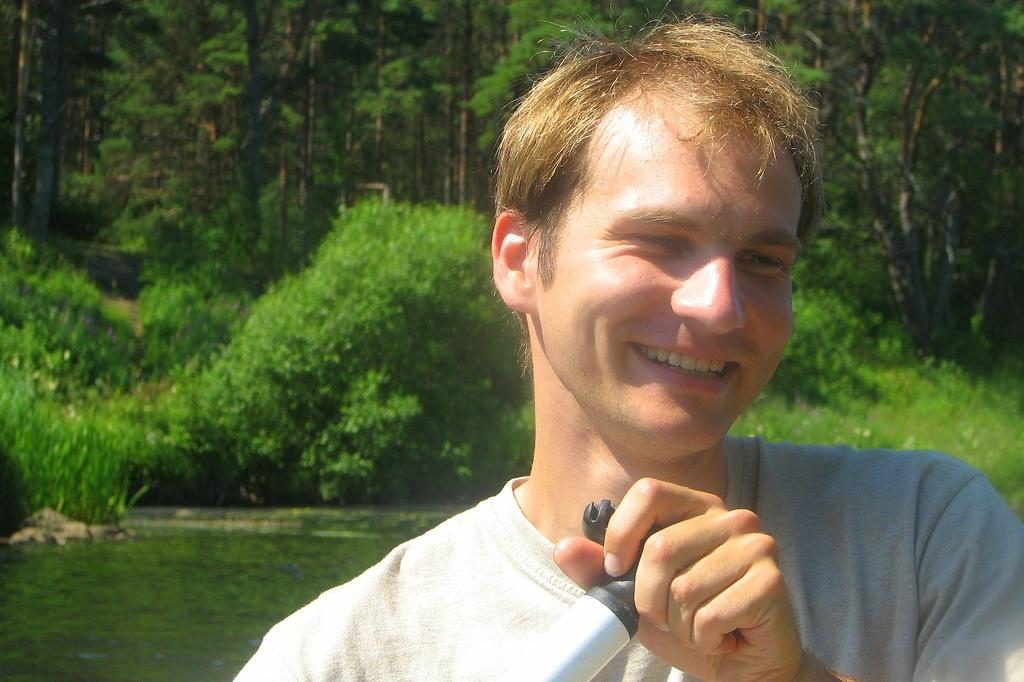Who is the main subject in the image? There is a man in the image. What is the man wearing? The man is wearing a white t-shirt. What is the man's facial expression in the image? The man is smiling. What is the man doing in the image? The man is posing for the camera. What can be seen in the background of the image? There are huge trees in the background of the image. What is the man's aunt doing on the stage in the image? There is no mention of an aunt or a stage in the image; it features a man posing for the camera with huge trees in the background. 